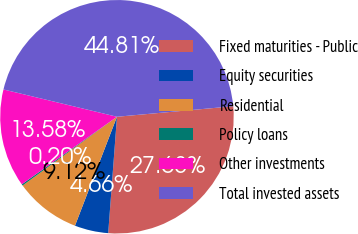Convert chart. <chart><loc_0><loc_0><loc_500><loc_500><pie_chart><fcel>Fixed maturities - Public<fcel>Equity securities<fcel>Residential<fcel>Policy loans<fcel>Other investments<fcel>Total invested assets<nl><fcel>27.63%<fcel>4.66%<fcel>9.12%<fcel>0.2%<fcel>13.58%<fcel>44.81%<nl></chart> 